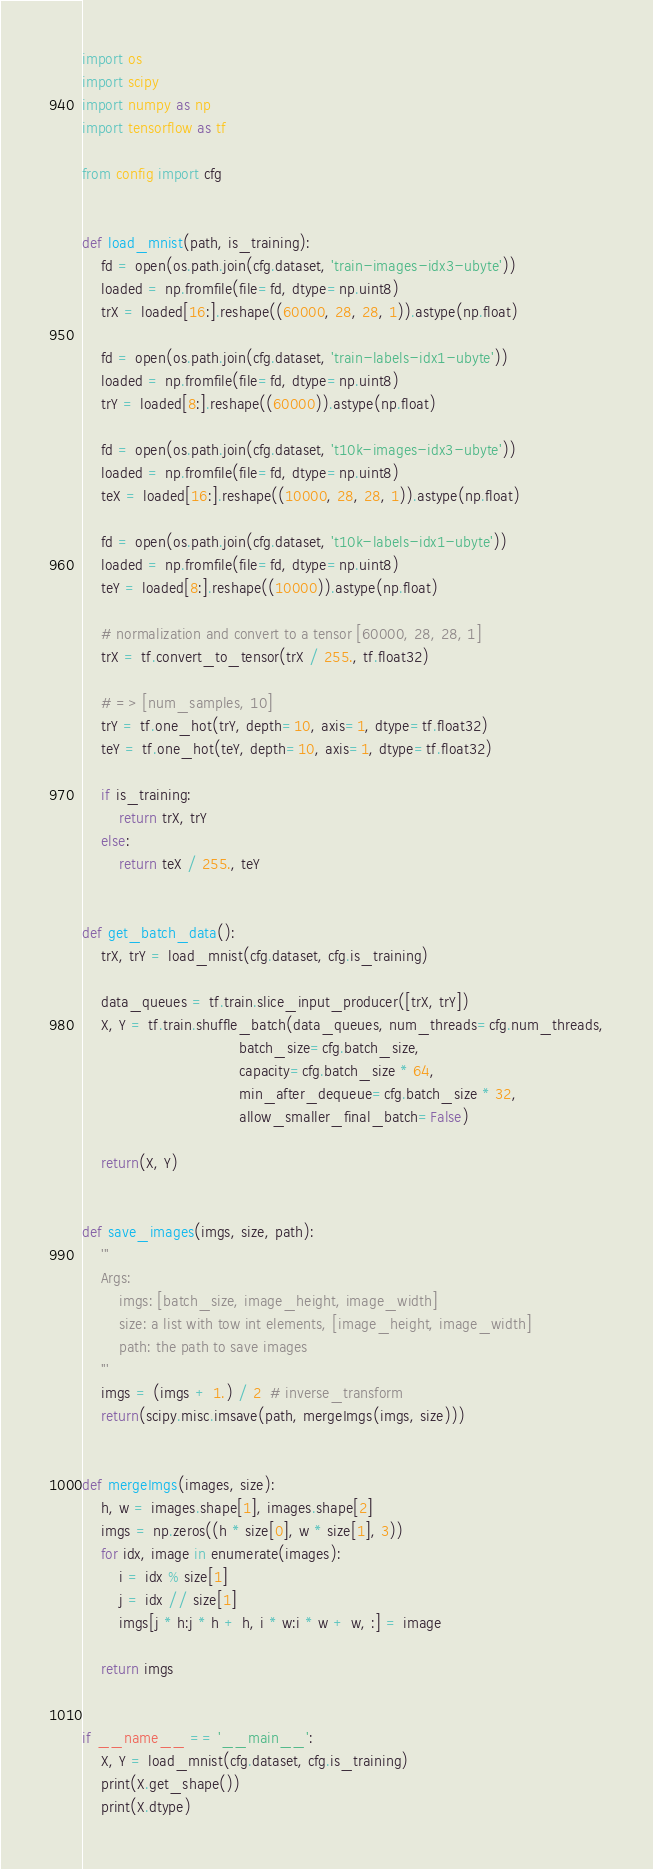Convert code to text. <code><loc_0><loc_0><loc_500><loc_500><_Python_>import os
import scipy
import numpy as np
import tensorflow as tf

from config import cfg


def load_mnist(path, is_training):
    fd = open(os.path.join(cfg.dataset, 'train-images-idx3-ubyte'))
    loaded = np.fromfile(file=fd, dtype=np.uint8)
    trX = loaded[16:].reshape((60000, 28, 28, 1)).astype(np.float)

    fd = open(os.path.join(cfg.dataset, 'train-labels-idx1-ubyte'))
    loaded = np.fromfile(file=fd, dtype=np.uint8)
    trY = loaded[8:].reshape((60000)).astype(np.float)

    fd = open(os.path.join(cfg.dataset, 't10k-images-idx3-ubyte'))
    loaded = np.fromfile(file=fd, dtype=np.uint8)
    teX = loaded[16:].reshape((10000, 28, 28, 1)).astype(np.float)

    fd = open(os.path.join(cfg.dataset, 't10k-labels-idx1-ubyte'))
    loaded = np.fromfile(file=fd, dtype=np.uint8)
    teY = loaded[8:].reshape((10000)).astype(np.float)

    # normalization and convert to a tensor [60000, 28, 28, 1]
    trX = tf.convert_to_tensor(trX / 255., tf.float32)

    # => [num_samples, 10]
    trY = tf.one_hot(trY, depth=10, axis=1, dtype=tf.float32)
    teY = tf.one_hot(teY, depth=10, axis=1, dtype=tf.float32)

    if is_training:
        return trX, trY
    else:
        return teX / 255., teY


def get_batch_data():
    trX, trY = load_mnist(cfg.dataset, cfg.is_training)

    data_queues = tf.train.slice_input_producer([trX, trY])
    X, Y = tf.train.shuffle_batch(data_queues, num_threads=cfg.num_threads,
                                  batch_size=cfg.batch_size,
                                  capacity=cfg.batch_size * 64,
                                  min_after_dequeue=cfg.batch_size * 32,
                                  allow_smaller_final_batch=False)

    return(X, Y)


def save_images(imgs, size, path):
    '''
    Args:
        imgs: [batch_size, image_height, image_width]
        size: a list with tow int elements, [image_height, image_width]
        path: the path to save images
    '''
    imgs = (imgs + 1.) / 2  # inverse_transform
    return(scipy.misc.imsave(path, mergeImgs(imgs, size)))


def mergeImgs(images, size):
    h, w = images.shape[1], images.shape[2]
    imgs = np.zeros((h * size[0], w * size[1], 3))
    for idx, image in enumerate(images):
        i = idx % size[1]
        j = idx // size[1]
        imgs[j * h:j * h + h, i * w:i * w + w, :] = image

    return imgs


if __name__ == '__main__':
    X, Y = load_mnist(cfg.dataset, cfg.is_training)
    print(X.get_shape())
    print(X.dtype)</code> 